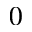Convert formula to latex. <formula><loc_0><loc_0><loc_500><loc_500>0</formula> 